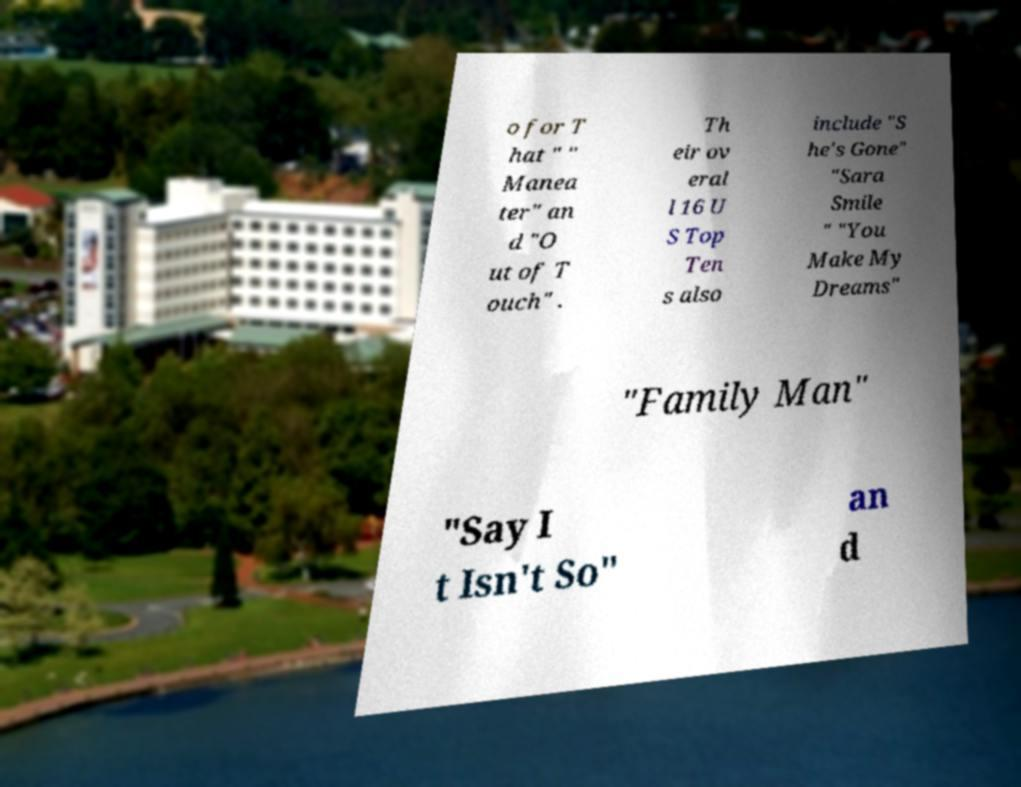Can you accurately transcribe the text from the provided image for me? o for T hat " " Manea ter" an d "O ut of T ouch" . Th eir ov eral l 16 U S Top Ten s also include "S he's Gone" "Sara Smile " "You Make My Dreams" "Family Man" "Say I t Isn't So" an d 